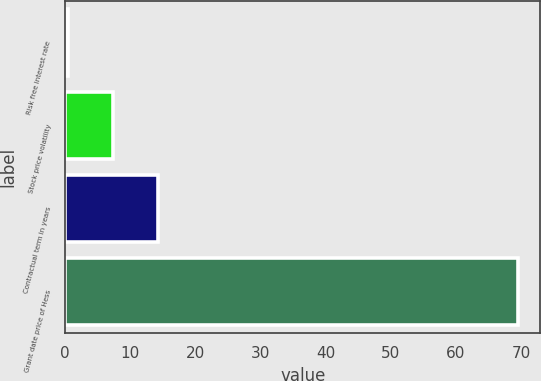<chart> <loc_0><loc_0><loc_500><loc_500><bar_chart><fcel>Risk free interest rate<fcel>Stock price volatility<fcel>Contractual term in years<fcel>Grant date price of Hess<nl><fcel>0.36<fcel>7.27<fcel>14.18<fcel>69.49<nl></chart> 